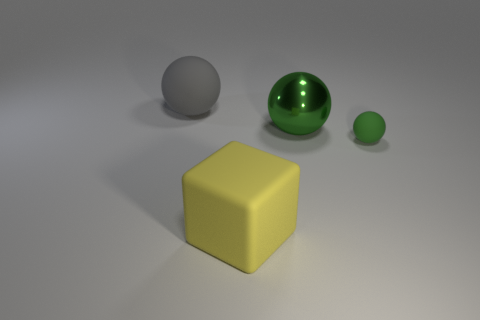What color is the rubber thing behind the small green sphere?
Make the answer very short. Gray. The green sphere that is made of the same material as the large gray object is what size?
Your answer should be compact. Small. There is a yellow rubber block; is it the same size as the rubber sphere left of the yellow object?
Your answer should be very brief. Yes. There is a thing that is right of the metal object; what is its material?
Offer a terse response. Rubber. How many gray objects are to the left of the matte sphere right of the big block?
Your answer should be compact. 1. Is there a large gray object that has the same shape as the big green metallic thing?
Your answer should be very brief. Yes. Do the rubber sphere to the left of the matte block and the rubber object on the right side of the big rubber cube have the same size?
Provide a short and direct response. No. There is a large matte object that is in front of the sphere left of the yellow matte object; what shape is it?
Your response must be concise. Cube. What number of green metallic balls are the same size as the yellow object?
Make the answer very short. 1. Are there any tiny purple balls?
Your answer should be compact. No. 